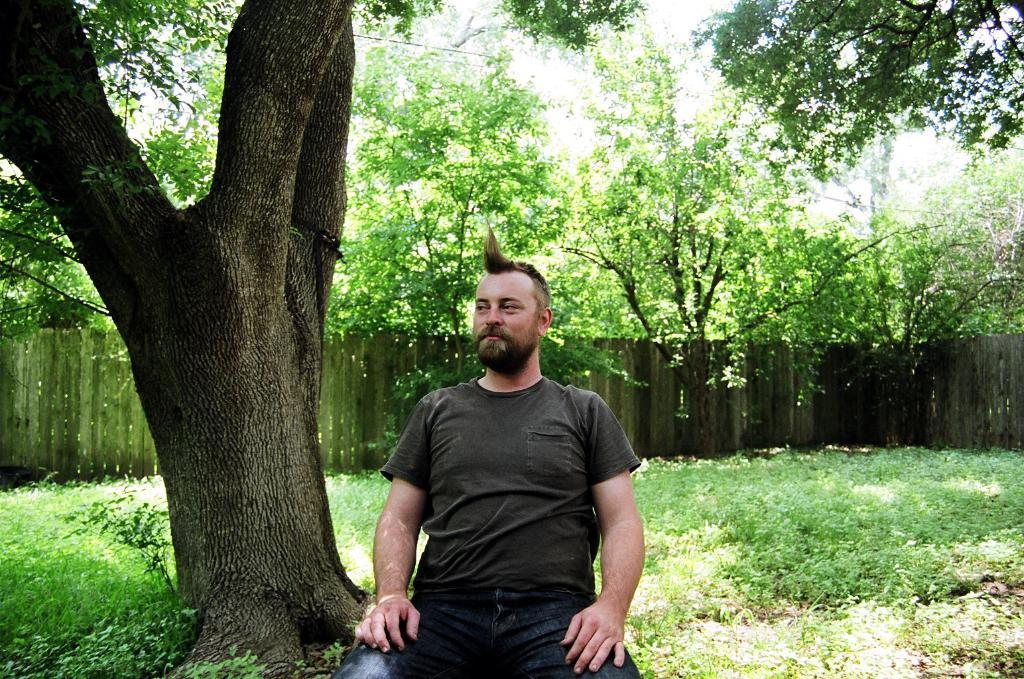What is the man in the image doing? The man is sitting beside the bark of a tree in the image. What type of vegetation can be seen in the image? There are plants and grass visible in the image. What kind of barrier is present in the image? There is a wooden fence in the image. How many trees are grouped together in the image? There is a group of trees in the image. What part of the natural environment is visible in the image? The sky is visible in the image. What type of insurance policy does the stream in the image provide? There is no stream present in the image, so it cannot provide any insurance policy. 